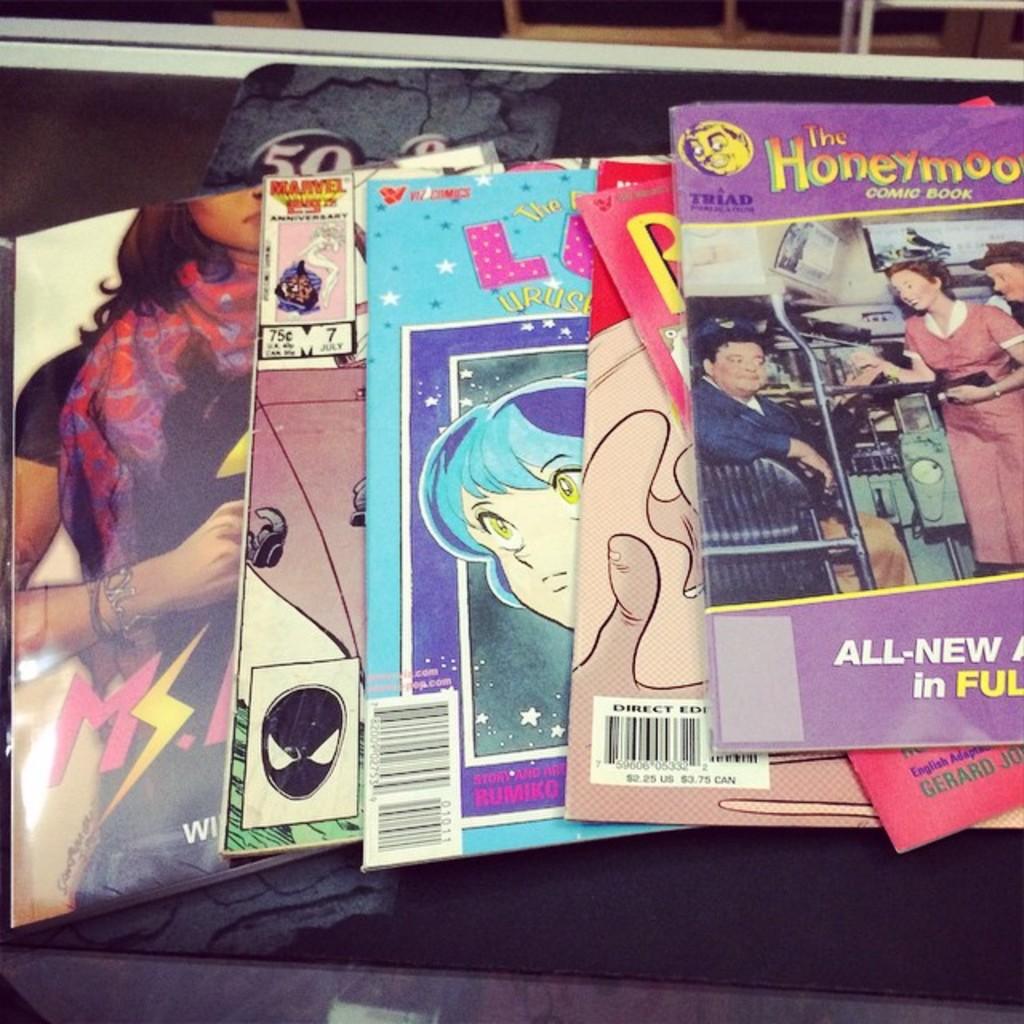What comic is on top?
Give a very brief answer. The honeymooners. 